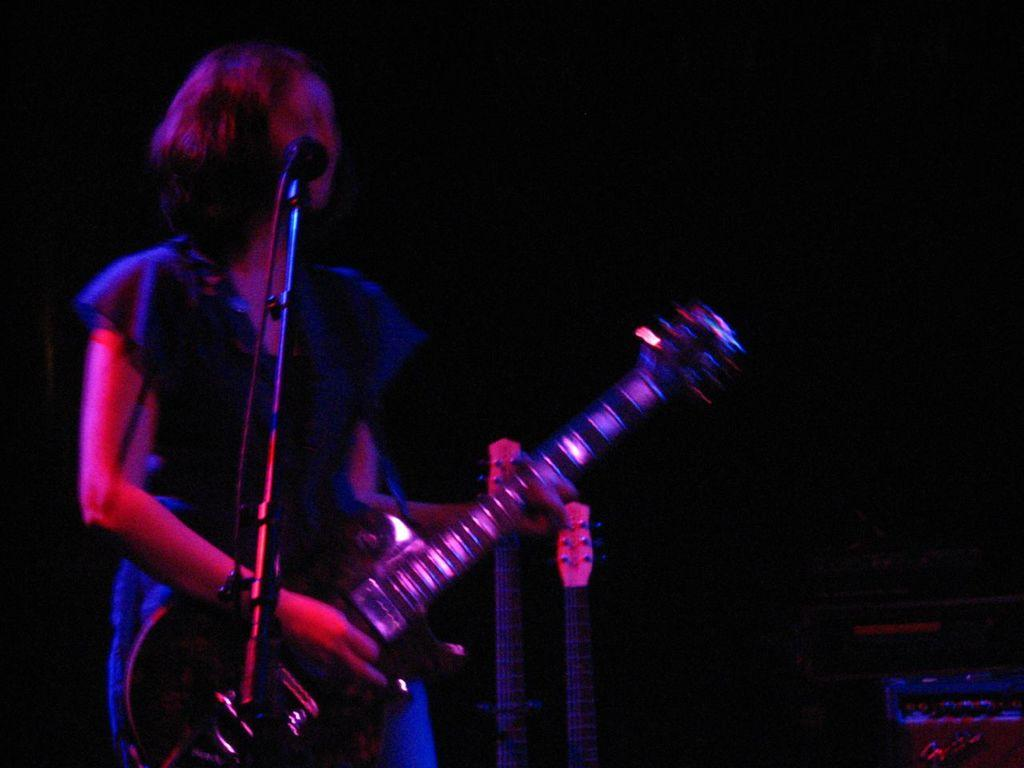What is the woman in the image doing? The woman is playing a guitar in the image. What object is present that is typically used for amplifying sound? There is a microphone in the image. What other objects are present that are related to sound production? There are sound boxes in the image. What can be inferred about the lighting conditions in the image? The background of the image is dark, and it may have been taken during the night. Where might this scene be taking place? The scene appears to be on a stage. What type of wound can be seen on the woman's hand while she is playing the guitar? There is no wound visible on the woman's hand in the image. What type of writing instrument is the woman using to write a song while playing the guitar? The woman is not writing a song in the image; she is only playing the guitar. 